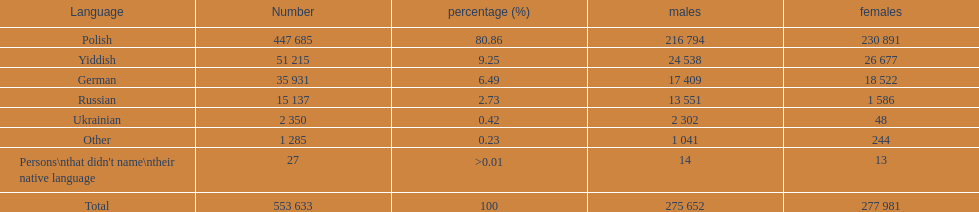Which is the least spoken language? Ukrainian. Give me the full table as a dictionary. {'header': ['Language', 'Number', 'percentage (%)', 'males', 'females'], 'rows': [['Polish', '447 685', '80.86', '216 794', '230 891'], ['Yiddish', '51 215', '9.25', '24 538', '26 677'], ['German', '35 931', '6.49', '17 409', '18 522'], ['Russian', '15 137', '2.73', '13 551', '1 586'], ['Ukrainian', '2 350', '0.42', '2 302', '48'], ['Other', '1 285', '0.23', '1 041', '244'], ["Persons\\nthat didn't name\\ntheir native language", '27', '>0.01', '14', '13'], ['Total', '553 633', '100', '275 652', '277 981']]} 